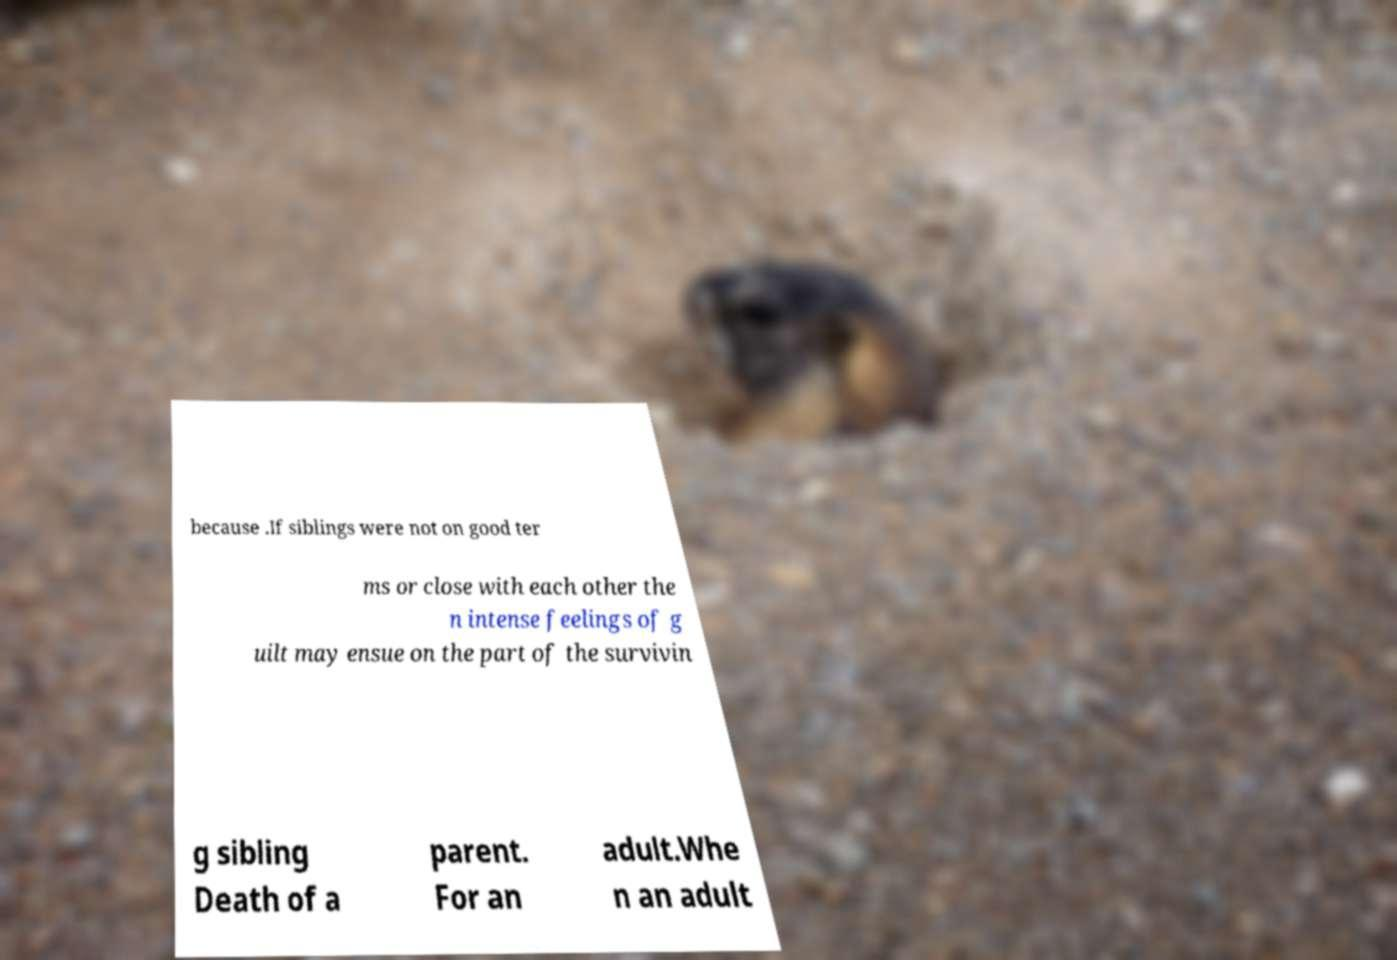Please identify and transcribe the text found in this image. because .If siblings were not on good ter ms or close with each other the n intense feelings of g uilt may ensue on the part of the survivin g sibling Death of a parent. For an adult.Whe n an adult 